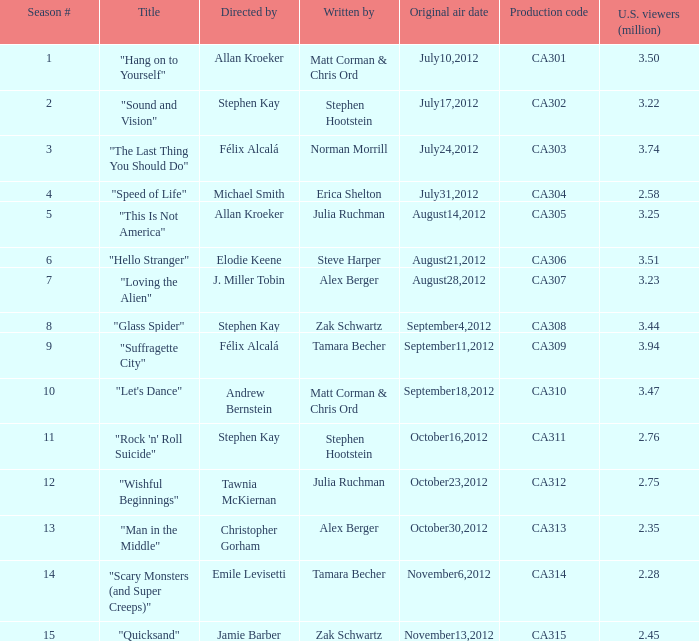Who directed the episode with production code ca303? Félix Alcalá. 